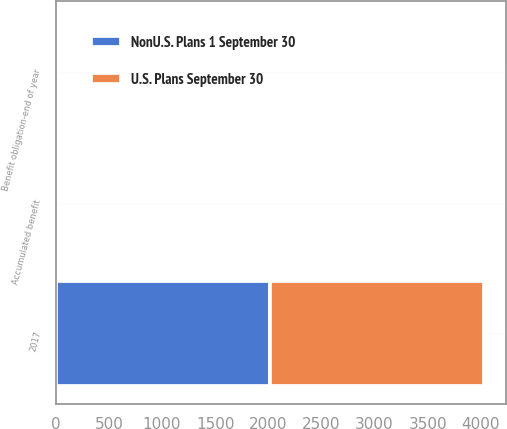Convert chart to OTSL. <chart><loc_0><loc_0><loc_500><loc_500><stacked_bar_chart><ecel><fcel>2017<fcel>Accumulated benefit<fcel>Benefit obligation-end of year<nl><fcel>NonU.S. Plans 1 September 30<fcel>2016<fcel>16<fcel>16<nl><fcel>U.S. Plans September 30<fcel>2017<fcel>5<fcel>5<nl></chart> 